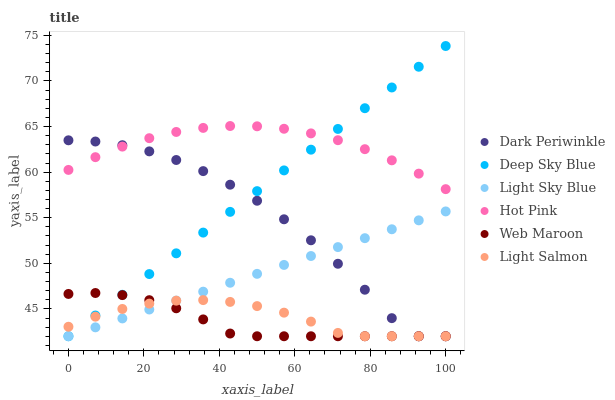Does Web Maroon have the minimum area under the curve?
Answer yes or no. Yes. Does Hot Pink have the maximum area under the curve?
Answer yes or no. Yes. Does Hot Pink have the minimum area under the curve?
Answer yes or no. No. Does Web Maroon have the maximum area under the curve?
Answer yes or no. No. Is Light Sky Blue the smoothest?
Answer yes or no. Yes. Is Dark Periwinkle the roughest?
Answer yes or no. Yes. Is Hot Pink the smoothest?
Answer yes or no. No. Is Hot Pink the roughest?
Answer yes or no. No. Does Light Salmon have the lowest value?
Answer yes or no. Yes. Does Hot Pink have the lowest value?
Answer yes or no. No. Does Deep Sky Blue have the highest value?
Answer yes or no. Yes. Does Hot Pink have the highest value?
Answer yes or no. No. Is Light Sky Blue less than Hot Pink?
Answer yes or no. Yes. Is Hot Pink greater than Light Salmon?
Answer yes or no. Yes. Does Deep Sky Blue intersect Web Maroon?
Answer yes or no. Yes. Is Deep Sky Blue less than Web Maroon?
Answer yes or no. No. Is Deep Sky Blue greater than Web Maroon?
Answer yes or no. No. Does Light Sky Blue intersect Hot Pink?
Answer yes or no. No. 